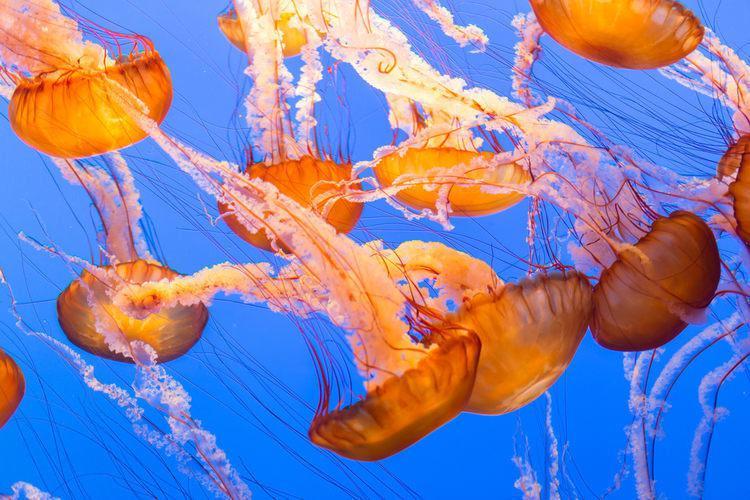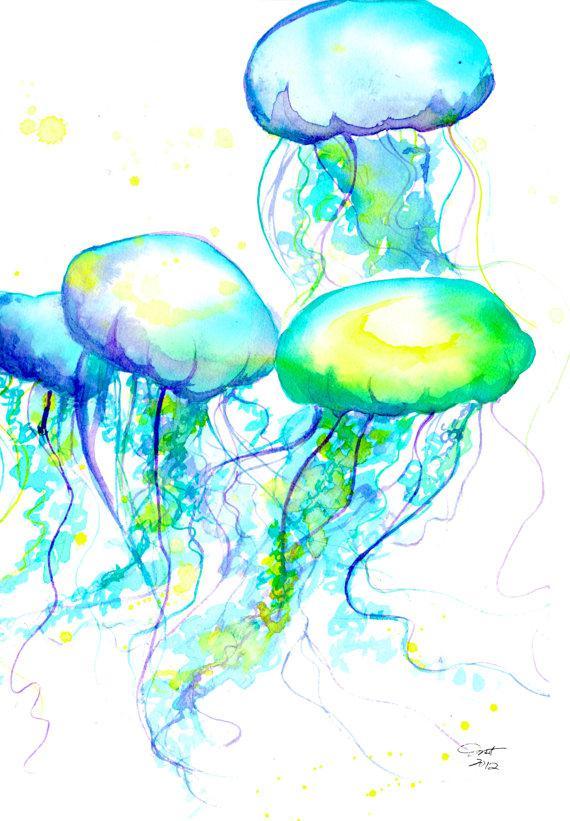The first image is the image on the left, the second image is the image on the right. For the images shown, is this caption "There is at least one person in the image on the right" true? Answer yes or no. No. 